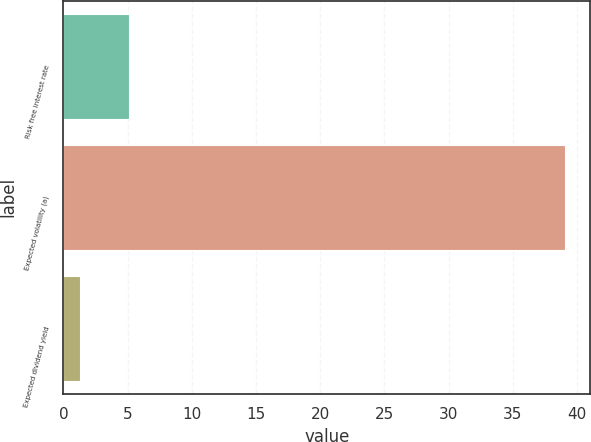Convert chart. <chart><loc_0><loc_0><loc_500><loc_500><bar_chart><fcel>Risk free interest rate<fcel>Expected volatility (a)<fcel>Expected dividend yield<nl><fcel>5.09<fcel>39.06<fcel>1.32<nl></chart> 